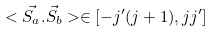<formula> <loc_0><loc_0><loc_500><loc_500>< \vec { S _ { a } } . \vec { S _ { b } } > \in [ - j ^ { \prime } ( j + 1 ) , j j ^ { \prime } ]</formula> 